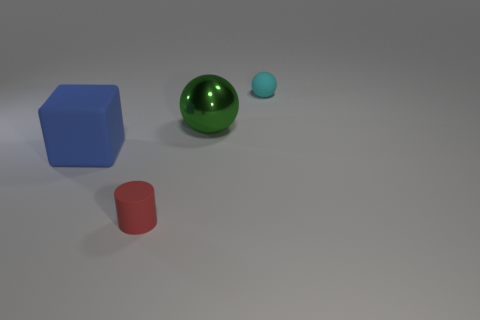Add 2 blue rubber cubes. How many objects exist? 6 Subtract all cylinders. How many objects are left? 3 Add 3 tiny red rubber objects. How many tiny red rubber objects are left? 4 Add 3 red cylinders. How many red cylinders exist? 4 Subtract 0 blue cylinders. How many objects are left? 4 Subtract all tiny rubber balls. Subtract all large blue matte blocks. How many objects are left? 2 